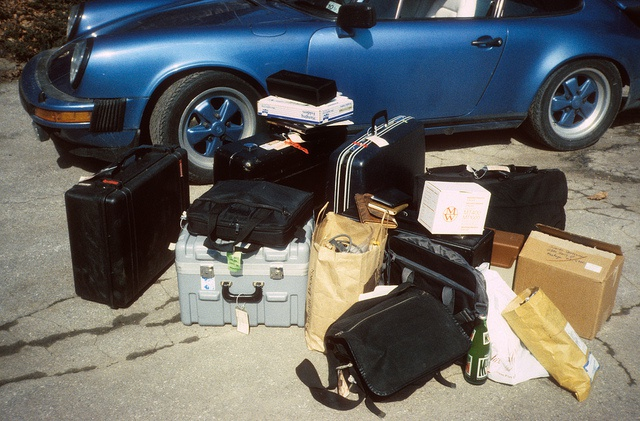Describe the objects in this image and their specific colors. I can see car in black, navy, and blue tones, suitcase in black, gray, maroon, and darkgray tones, handbag in black and gray tones, suitcase in black, lightgray, darkgray, and gray tones, and suitcase in black, lightgray, tan, and gray tones in this image. 